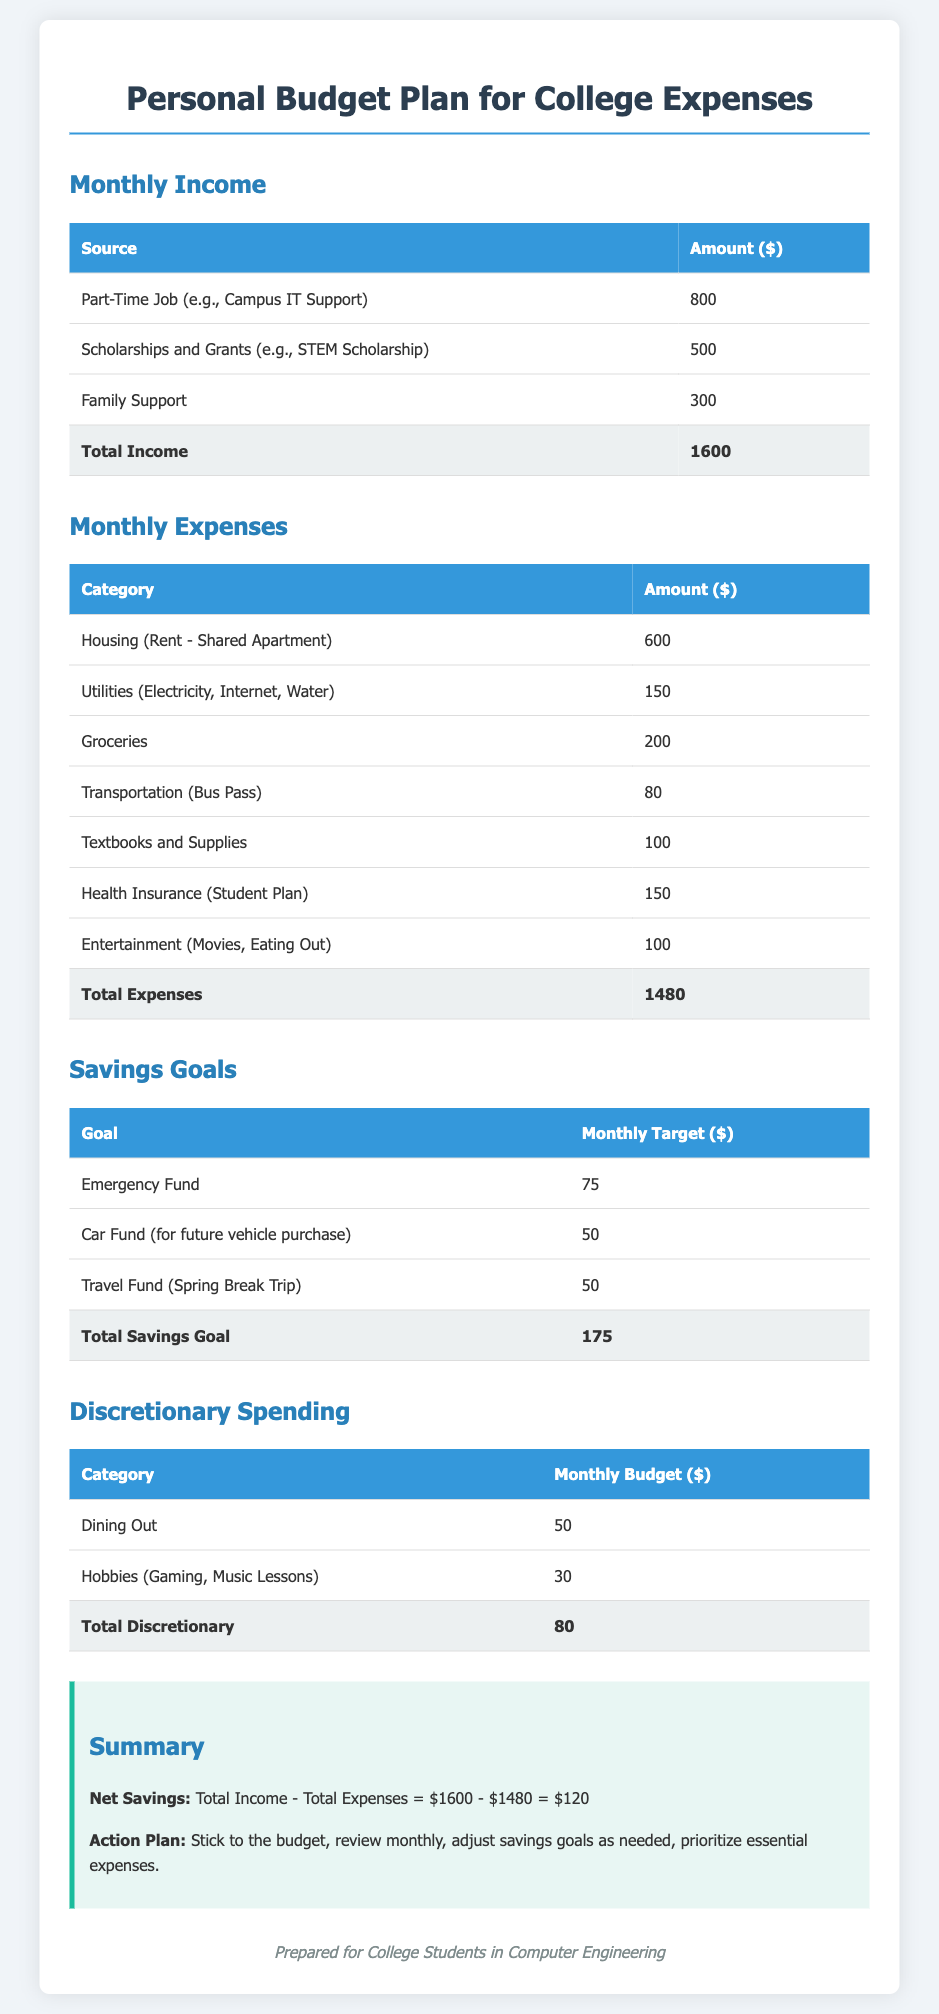What is the total monthly income? The total monthly income is calculated by adding all income sources together, which amounts to $800 + $500 + $300 = $1600.
Answer: $1600 What is the budget for groceries each month? The budget for groceries is listed directly in the expenses section of the document.
Answer: $200 How much is allocated to the Emergency Fund? The Monthly Target for the Emergency Fund is specified in the savings goals section.
Answer: $75 What is the total amount for discretionary spending? The total discretionary spending is summed from the individual categories within that section, which is $50 + $30 = $80.
Answer: $80 What is the net savings calculated in the summary? The net savings is found by subtracting total expenses from total income, which is $1600 - $1480.
Answer: $120 How much does the student spend on health insurance? The amount spent on health insurance is detailed in the monthly expenses table.
Answer: $150 What is the total monthly expenses amount? The total monthly expenses is calculated by summing all expense categories, totaling $600 + $150 + $200 + $80 + $100 + $150 + $100 = $1480.
Answer: $1480 What is the monthly target for the Travel Fund? The monthly target for the Travel Fund is specified under the savings goals section of the document.
Answer: $50 